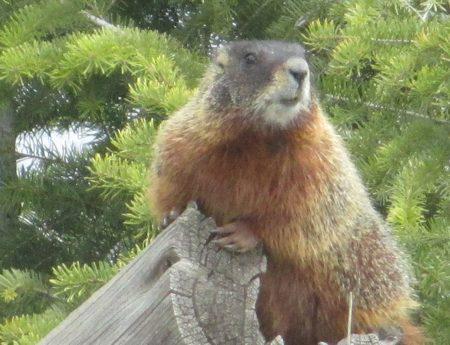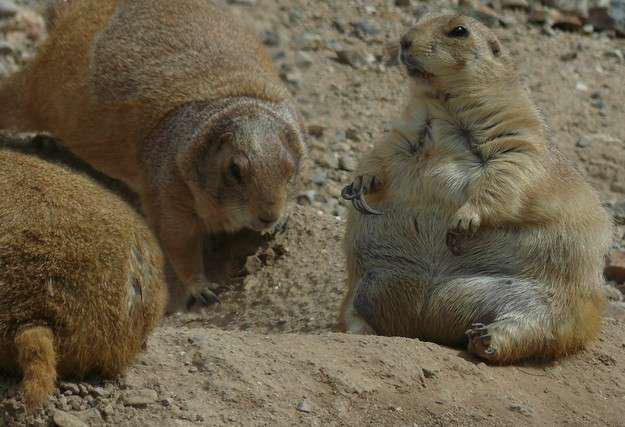The first image is the image on the left, the second image is the image on the right. Examine the images to the left and right. Is the description "In at least one of the images, there is just one marmot" accurate? Answer yes or no. Yes. The first image is the image on the left, the second image is the image on the right. Examine the images to the left and right. Is the description "At least one image has exactly one animal." accurate? Answer yes or no. Yes. 